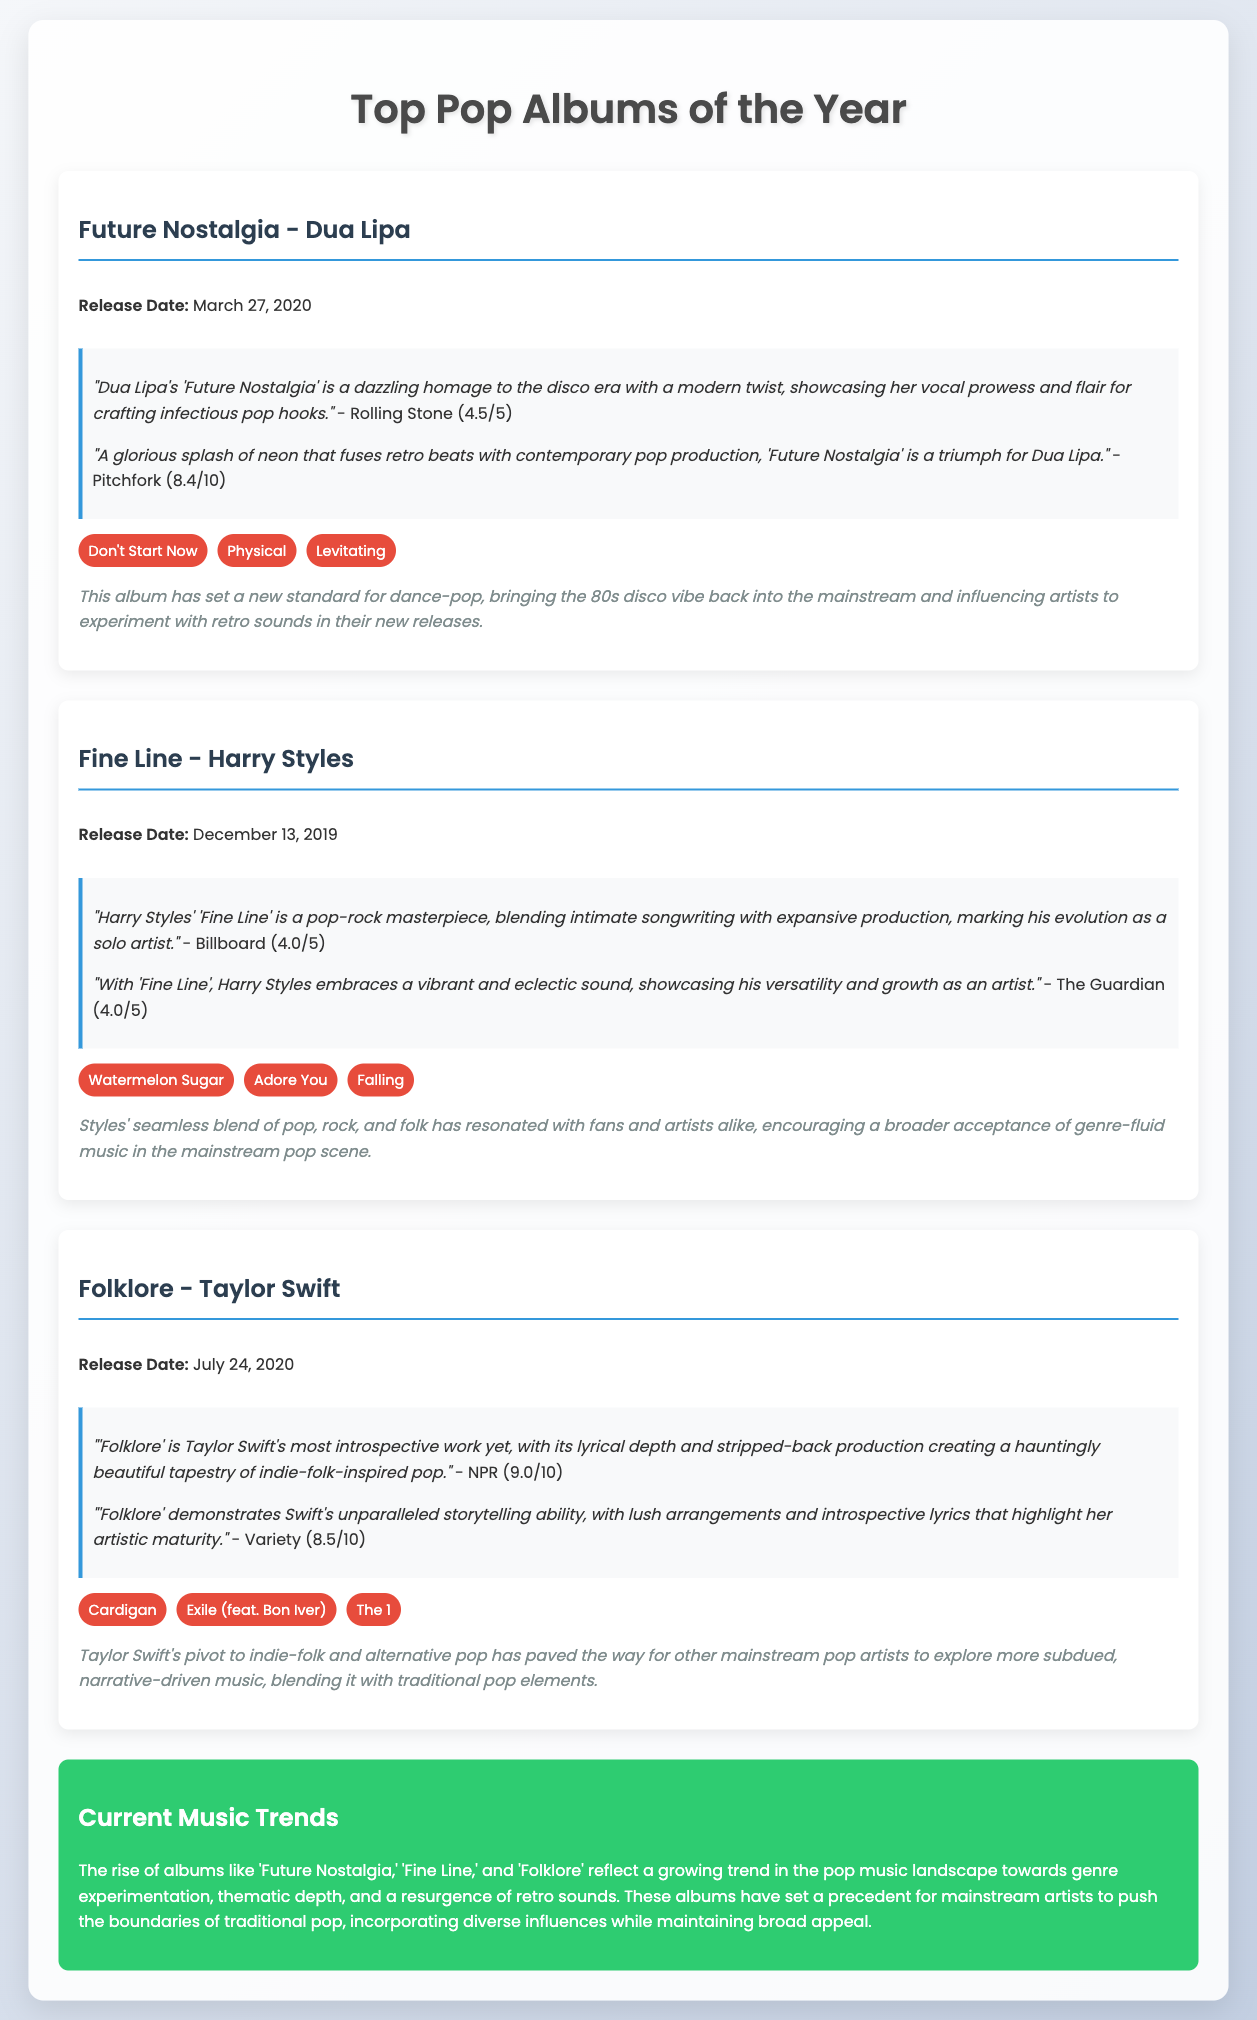what is the release date of "Future Nostalgia"? The release date of "Future Nostalgia" is directly stated in the document.
Answer: March 27, 2020 who is the artist of the album "Fine Line"? The artist associated with the album "Fine Line" is provided in the album title section.
Answer: Harry Styles what score did Rolling Stone give "Folklore"? The score given by Rolling Stone for "Folklore" can be found in the reviews section of the document.
Answer: 9.0/10 which track from "Future Nostalgia" is listed as a standout? The standout tracks for each album are named in a specific section of the document.
Answer: Don't Start Now how does "Folklore" influence current music trends? The influence of "Folklore" on current music trends is explicitly mentioned in the influence section of the album.
Answer: Paved the way for other mainstream pop artists to explore subdued music what is a common theme among the listed albums? The document discusses themes and trends among the albums, helping to establish commonalities.
Answer: Genre experimentation which two albums are noted for influencing retro sounds? The specific albums influencing retro sounds are mentioned in the influence section.
Answer: Future Nostalgia and Folklore what is the overall score given to "Fine Line" by The Guardian? The overall score from The Guardian for "Fine Line" is included in the reviews section.
Answer: 4.0/5 